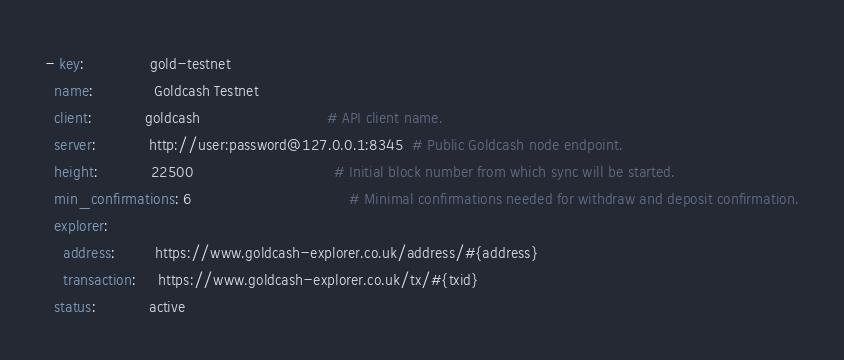Convert code to text. <code><loc_0><loc_0><loc_500><loc_500><_YAML_>- key:               gold-testnet
  name:              Goldcash Testnet
  client:            goldcash                             # API client name.
  server:            http://user:password@127.0.0.1:8345  # Public Goldcash node endpoint.
  height:            22500                                # Initial block number from which sync will be started.
  min_confirmations: 6                                    # Minimal confirmations needed for withdraw and deposit confirmation.
  explorer:
    address:         https://www.goldcash-explorer.co.uk/address/#{address}
    transaction:     https://www.goldcash-explorer.co.uk/tx/#{txid}
  status:            active
</code> 